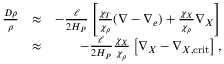<formula> <loc_0><loc_0><loc_500><loc_500>\begin{array} { r l r } { { \frac { D \rho } { \rho } } } & { \approx } & { - { \frac { \ell } { 2 H _ { P } } } \left [ { \frac { \chi _ { T } } { \chi _ { \rho } } } ( \nabla - \nabla _ { e } ) + { \frac { \chi _ { X } } { \chi _ { \rho } } } \nabla _ { X } \right ] } \\ & { \approx } & { - { \frac { \ell } { 2 H _ { P } } } { \frac { \chi _ { X } } { \chi _ { \rho } } } \left [ \nabla _ { X } - \nabla _ { X , c r i t } \right ] , } \end{array}</formula> 